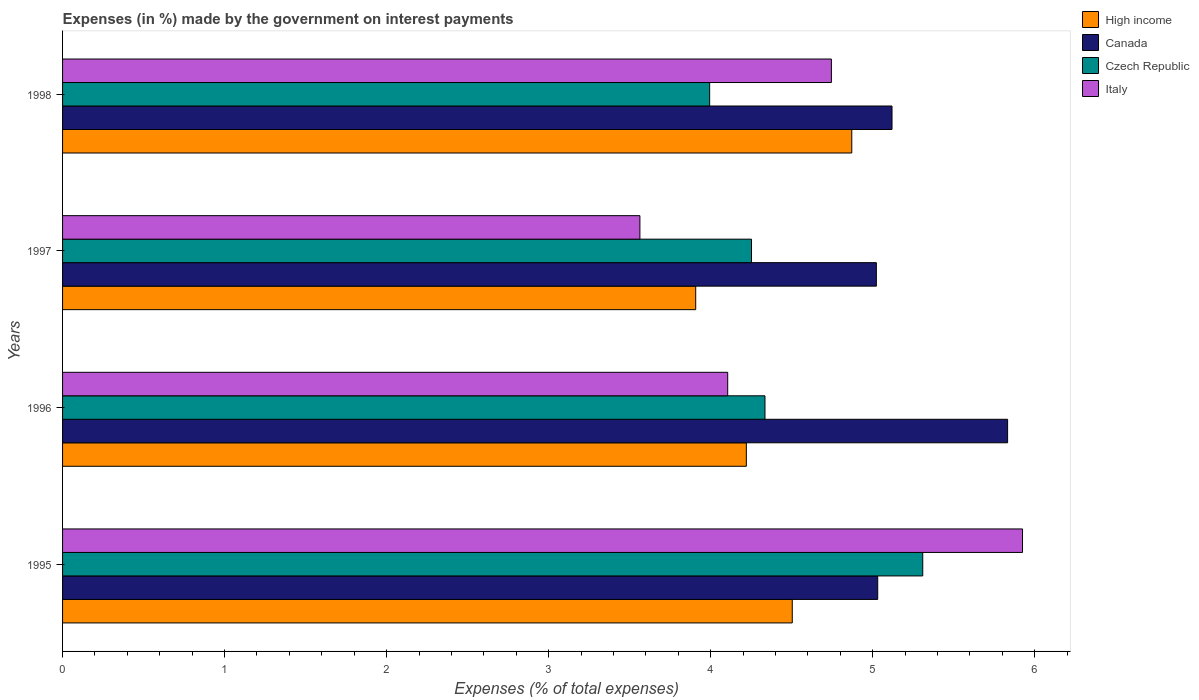How many groups of bars are there?
Make the answer very short. 4. Are the number of bars per tick equal to the number of legend labels?
Ensure brevity in your answer.  Yes. Are the number of bars on each tick of the Y-axis equal?
Your answer should be very brief. Yes. What is the label of the 4th group of bars from the top?
Provide a succinct answer. 1995. In how many cases, is the number of bars for a given year not equal to the number of legend labels?
Offer a terse response. 0. What is the percentage of expenses made by the government on interest payments in High income in 1998?
Give a very brief answer. 4.87. Across all years, what is the maximum percentage of expenses made by the government on interest payments in Italy?
Provide a short and direct response. 5.93. Across all years, what is the minimum percentage of expenses made by the government on interest payments in Italy?
Make the answer very short. 3.56. In which year was the percentage of expenses made by the government on interest payments in Italy maximum?
Your answer should be very brief. 1995. In which year was the percentage of expenses made by the government on interest payments in Czech Republic minimum?
Offer a terse response. 1998. What is the total percentage of expenses made by the government on interest payments in Czech Republic in the graph?
Make the answer very short. 17.89. What is the difference between the percentage of expenses made by the government on interest payments in Canada in 1995 and that in 1996?
Offer a very short reply. -0.8. What is the difference between the percentage of expenses made by the government on interest payments in High income in 1996 and the percentage of expenses made by the government on interest payments in Italy in 1997?
Give a very brief answer. 0.66. What is the average percentage of expenses made by the government on interest payments in Canada per year?
Make the answer very short. 5.25. In the year 1996, what is the difference between the percentage of expenses made by the government on interest payments in High income and percentage of expenses made by the government on interest payments in Canada?
Keep it short and to the point. -1.61. What is the ratio of the percentage of expenses made by the government on interest payments in High income in 1995 to that in 1997?
Keep it short and to the point. 1.15. Is the percentage of expenses made by the government on interest payments in Canada in 1997 less than that in 1998?
Ensure brevity in your answer.  Yes. What is the difference between the highest and the second highest percentage of expenses made by the government on interest payments in Czech Republic?
Your answer should be very brief. 0.97. What is the difference between the highest and the lowest percentage of expenses made by the government on interest payments in Canada?
Give a very brief answer. 0.81. In how many years, is the percentage of expenses made by the government on interest payments in Canada greater than the average percentage of expenses made by the government on interest payments in Canada taken over all years?
Offer a terse response. 1. Is the sum of the percentage of expenses made by the government on interest payments in High income in 1996 and 1998 greater than the maximum percentage of expenses made by the government on interest payments in Canada across all years?
Provide a short and direct response. Yes. Is it the case that in every year, the sum of the percentage of expenses made by the government on interest payments in High income and percentage of expenses made by the government on interest payments in Czech Republic is greater than the sum of percentage of expenses made by the government on interest payments in Italy and percentage of expenses made by the government on interest payments in Canada?
Ensure brevity in your answer.  No. Is it the case that in every year, the sum of the percentage of expenses made by the government on interest payments in High income and percentage of expenses made by the government on interest payments in Italy is greater than the percentage of expenses made by the government on interest payments in Czech Republic?
Your response must be concise. Yes. How many bars are there?
Make the answer very short. 16. Are all the bars in the graph horizontal?
Give a very brief answer. Yes. What is the difference between two consecutive major ticks on the X-axis?
Give a very brief answer. 1. Where does the legend appear in the graph?
Provide a succinct answer. Top right. How are the legend labels stacked?
Make the answer very short. Vertical. What is the title of the graph?
Your answer should be very brief. Expenses (in %) made by the government on interest payments. What is the label or title of the X-axis?
Your answer should be very brief. Expenses (% of total expenses). What is the label or title of the Y-axis?
Make the answer very short. Years. What is the Expenses (% of total expenses) of High income in 1995?
Your answer should be compact. 4.5. What is the Expenses (% of total expenses) of Canada in 1995?
Your answer should be compact. 5.03. What is the Expenses (% of total expenses) in Czech Republic in 1995?
Your response must be concise. 5.31. What is the Expenses (% of total expenses) in Italy in 1995?
Make the answer very short. 5.93. What is the Expenses (% of total expenses) in High income in 1996?
Keep it short and to the point. 4.22. What is the Expenses (% of total expenses) of Canada in 1996?
Provide a short and direct response. 5.83. What is the Expenses (% of total expenses) in Czech Republic in 1996?
Your response must be concise. 4.34. What is the Expenses (% of total expenses) in Italy in 1996?
Provide a succinct answer. 4.11. What is the Expenses (% of total expenses) in High income in 1997?
Provide a short and direct response. 3.91. What is the Expenses (% of total expenses) in Canada in 1997?
Provide a succinct answer. 5.02. What is the Expenses (% of total expenses) in Czech Republic in 1997?
Your answer should be very brief. 4.25. What is the Expenses (% of total expenses) of Italy in 1997?
Your answer should be compact. 3.56. What is the Expenses (% of total expenses) in High income in 1998?
Offer a very short reply. 4.87. What is the Expenses (% of total expenses) of Canada in 1998?
Make the answer very short. 5.12. What is the Expenses (% of total expenses) of Czech Republic in 1998?
Your response must be concise. 3.99. What is the Expenses (% of total expenses) of Italy in 1998?
Give a very brief answer. 4.75. Across all years, what is the maximum Expenses (% of total expenses) of High income?
Offer a terse response. 4.87. Across all years, what is the maximum Expenses (% of total expenses) in Canada?
Provide a succinct answer. 5.83. Across all years, what is the maximum Expenses (% of total expenses) in Czech Republic?
Provide a succinct answer. 5.31. Across all years, what is the maximum Expenses (% of total expenses) of Italy?
Ensure brevity in your answer.  5.93. Across all years, what is the minimum Expenses (% of total expenses) of High income?
Ensure brevity in your answer.  3.91. Across all years, what is the minimum Expenses (% of total expenses) in Canada?
Offer a terse response. 5.02. Across all years, what is the minimum Expenses (% of total expenses) in Czech Republic?
Your answer should be very brief. 3.99. Across all years, what is the minimum Expenses (% of total expenses) in Italy?
Your response must be concise. 3.56. What is the total Expenses (% of total expenses) in High income in the graph?
Give a very brief answer. 17.5. What is the total Expenses (% of total expenses) in Canada in the graph?
Make the answer very short. 21.01. What is the total Expenses (% of total expenses) of Czech Republic in the graph?
Provide a short and direct response. 17.89. What is the total Expenses (% of total expenses) of Italy in the graph?
Provide a short and direct response. 18.34. What is the difference between the Expenses (% of total expenses) of High income in 1995 and that in 1996?
Your answer should be very brief. 0.28. What is the difference between the Expenses (% of total expenses) of Canada in 1995 and that in 1996?
Make the answer very short. -0.8. What is the difference between the Expenses (% of total expenses) of Czech Republic in 1995 and that in 1996?
Keep it short and to the point. 0.97. What is the difference between the Expenses (% of total expenses) in Italy in 1995 and that in 1996?
Your response must be concise. 1.82. What is the difference between the Expenses (% of total expenses) of High income in 1995 and that in 1997?
Provide a succinct answer. 0.6. What is the difference between the Expenses (% of total expenses) of Canada in 1995 and that in 1997?
Make the answer very short. 0.01. What is the difference between the Expenses (% of total expenses) of Czech Republic in 1995 and that in 1997?
Your response must be concise. 1.06. What is the difference between the Expenses (% of total expenses) of Italy in 1995 and that in 1997?
Your answer should be very brief. 2.36. What is the difference between the Expenses (% of total expenses) of High income in 1995 and that in 1998?
Your response must be concise. -0.37. What is the difference between the Expenses (% of total expenses) of Canada in 1995 and that in 1998?
Ensure brevity in your answer.  -0.09. What is the difference between the Expenses (% of total expenses) in Czech Republic in 1995 and that in 1998?
Make the answer very short. 1.32. What is the difference between the Expenses (% of total expenses) in Italy in 1995 and that in 1998?
Offer a terse response. 1.18. What is the difference between the Expenses (% of total expenses) in High income in 1996 and that in 1997?
Your response must be concise. 0.31. What is the difference between the Expenses (% of total expenses) of Canada in 1996 and that in 1997?
Your answer should be compact. 0.81. What is the difference between the Expenses (% of total expenses) in Czech Republic in 1996 and that in 1997?
Your answer should be very brief. 0.08. What is the difference between the Expenses (% of total expenses) in Italy in 1996 and that in 1997?
Make the answer very short. 0.54. What is the difference between the Expenses (% of total expenses) of High income in 1996 and that in 1998?
Offer a terse response. -0.65. What is the difference between the Expenses (% of total expenses) of Canada in 1996 and that in 1998?
Your answer should be compact. 0.71. What is the difference between the Expenses (% of total expenses) of Czech Republic in 1996 and that in 1998?
Provide a short and direct response. 0.34. What is the difference between the Expenses (% of total expenses) in Italy in 1996 and that in 1998?
Make the answer very short. -0.64. What is the difference between the Expenses (% of total expenses) in High income in 1997 and that in 1998?
Give a very brief answer. -0.96. What is the difference between the Expenses (% of total expenses) of Canada in 1997 and that in 1998?
Your answer should be compact. -0.1. What is the difference between the Expenses (% of total expenses) in Czech Republic in 1997 and that in 1998?
Ensure brevity in your answer.  0.26. What is the difference between the Expenses (% of total expenses) of Italy in 1997 and that in 1998?
Ensure brevity in your answer.  -1.18. What is the difference between the Expenses (% of total expenses) in High income in 1995 and the Expenses (% of total expenses) in Canada in 1996?
Your answer should be compact. -1.33. What is the difference between the Expenses (% of total expenses) in High income in 1995 and the Expenses (% of total expenses) in Czech Republic in 1996?
Give a very brief answer. 0.17. What is the difference between the Expenses (% of total expenses) of High income in 1995 and the Expenses (% of total expenses) of Italy in 1996?
Your response must be concise. 0.4. What is the difference between the Expenses (% of total expenses) in Canada in 1995 and the Expenses (% of total expenses) in Czech Republic in 1996?
Offer a terse response. 0.7. What is the difference between the Expenses (% of total expenses) in Canada in 1995 and the Expenses (% of total expenses) in Italy in 1996?
Your answer should be very brief. 0.93. What is the difference between the Expenses (% of total expenses) in Czech Republic in 1995 and the Expenses (% of total expenses) in Italy in 1996?
Keep it short and to the point. 1.2. What is the difference between the Expenses (% of total expenses) of High income in 1995 and the Expenses (% of total expenses) of Canada in 1997?
Offer a terse response. -0.52. What is the difference between the Expenses (% of total expenses) of High income in 1995 and the Expenses (% of total expenses) of Czech Republic in 1997?
Your answer should be very brief. 0.25. What is the difference between the Expenses (% of total expenses) of High income in 1995 and the Expenses (% of total expenses) of Italy in 1997?
Offer a very short reply. 0.94. What is the difference between the Expenses (% of total expenses) of Canada in 1995 and the Expenses (% of total expenses) of Czech Republic in 1997?
Ensure brevity in your answer.  0.78. What is the difference between the Expenses (% of total expenses) in Canada in 1995 and the Expenses (% of total expenses) in Italy in 1997?
Offer a very short reply. 1.47. What is the difference between the Expenses (% of total expenses) in Czech Republic in 1995 and the Expenses (% of total expenses) in Italy in 1997?
Give a very brief answer. 1.75. What is the difference between the Expenses (% of total expenses) in High income in 1995 and the Expenses (% of total expenses) in Canada in 1998?
Your answer should be very brief. -0.62. What is the difference between the Expenses (% of total expenses) in High income in 1995 and the Expenses (% of total expenses) in Czech Republic in 1998?
Offer a terse response. 0.51. What is the difference between the Expenses (% of total expenses) of High income in 1995 and the Expenses (% of total expenses) of Italy in 1998?
Provide a succinct answer. -0.24. What is the difference between the Expenses (% of total expenses) in Canada in 1995 and the Expenses (% of total expenses) in Czech Republic in 1998?
Ensure brevity in your answer.  1.04. What is the difference between the Expenses (% of total expenses) in Canada in 1995 and the Expenses (% of total expenses) in Italy in 1998?
Give a very brief answer. 0.29. What is the difference between the Expenses (% of total expenses) of Czech Republic in 1995 and the Expenses (% of total expenses) of Italy in 1998?
Offer a terse response. 0.56. What is the difference between the Expenses (% of total expenses) in High income in 1996 and the Expenses (% of total expenses) in Canada in 1997?
Provide a short and direct response. -0.8. What is the difference between the Expenses (% of total expenses) in High income in 1996 and the Expenses (% of total expenses) in Czech Republic in 1997?
Ensure brevity in your answer.  -0.03. What is the difference between the Expenses (% of total expenses) of High income in 1996 and the Expenses (% of total expenses) of Italy in 1997?
Offer a terse response. 0.66. What is the difference between the Expenses (% of total expenses) in Canada in 1996 and the Expenses (% of total expenses) in Czech Republic in 1997?
Your response must be concise. 1.58. What is the difference between the Expenses (% of total expenses) in Canada in 1996 and the Expenses (% of total expenses) in Italy in 1997?
Provide a short and direct response. 2.27. What is the difference between the Expenses (% of total expenses) in Czech Republic in 1996 and the Expenses (% of total expenses) in Italy in 1997?
Give a very brief answer. 0.77. What is the difference between the Expenses (% of total expenses) in High income in 1996 and the Expenses (% of total expenses) in Canada in 1998?
Ensure brevity in your answer.  -0.9. What is the difference between the Expenses (% of total expenses) in High income in 1996 and the Expenses (% of total expenses) in Czech Republic in 1998?
Offer a very short reply. 0.23. What is the difference between the Expenses (% of total expenses) in High income in 1996 and the Expenses (% of total expenses) in Italy in 1998?
Give a very brief answer. -0.53. What is the difference between the Expenses (% of total expenses) in Canada in 1996 and the Expenses (% of total expenses) in Czech Republic in 1998?
Offer a very short reply. 1.84. What is the difference between the Expenses (% of total expenses) in Canada in 1996 and the Expenses (% of total expenses) in Italy in 1998?
Your response must be concise. 1.09. What is the difference between the Expenses (% of total expenses) in Czech Republic in 1996 and the Expenses (% of total expenses) in Italy in 1998?
Your answer should be very brief. -0.41. What is the difference between the Expenses (% of total expenses) in High income in 1997 and the Expenses (% of total expenses) in Canada in 1998?
Make the answer very short. -1.21. What is the difference between the Expenses (% of total expenses) of High income in 1997 and the Expenses (% of total expenses) of Czech Republic in 1998?
Keep it short and to the point. -0.09. What is the difference between the Expenses (% of total expenses) in High income in 1997 and the Expenses (% of total expenses) in Italy in 1998?
Your answer should be compact. -0.84. What is the difference between the Expenses (% of total expenses) of Canada in 1997 and the Expenses (% of total expenses) of Italy in 1998?
Provide a succinct answer. 0.28. What is the difference between the Expenses (% of total expenses) in Czech Republic in 1997 and the Expenses (% of total expenses) in Italy in 1998?
Provide a succinct answer. -0.49. What is the average Expenses (% of total expenses) of High income per year?
Offer a very short reply. 4.38. What is the average Expenses (% of total expenses) of Canada per year?
Provide a short and direct response. 5.25. What is the average Expenses (% of total expenses) in Czech Republic per year?
Your response must be concise. 4.47. What is the average Expenses (% of total expenses) in Italy per year?
Offer a very short reply. 4.58. In the year 1995, what is the difference between the Expenses (% of total expenses) in High income and Expenses (% of total expenses) in Canada?
Provide a short and direct response. -0.53. In the year 1995, what is the difference between the Expenses (% of total expenses) in High income and Expenses (% of total expenses) in Czech Republic?
Your answer should be compact. -0.81. In the year 1995, what is the difference between the Expenses (% of total expenses) of High income and Expenses (% of total expenses) of Italy?
Offer a very short reply. -1.42. In the year 1995, what is the difference between the Expenses (% of total expenses) in Canada and Expenses (% of total expenses) in Czech Republic?
Provide a short and direct response. -0.28. In the year 1995, what is the difference between the Expenses (% of total expenses) of Canada and Expenses (% of total expenses) of Italy?
Provide a short and direct response. -0.89. In the year 1995, what is the difference between the Expenses (% of total expenses) in Czech Republic and Expenses (% of total expenses) in Italy?
Provide a short and direct response. -0.62. In the year 1996, what is the difference between the Expenses (% of total expenses) of High income and Expenses (% of total expenses) of Canada?
Ensure brevity in your answer.  -1.61. In the year 1996, what is the difference between the Expenses (% of total expenses) in High income and Expenses (% of total expenses) in Czech Republic?
Offer a terse response. -0.12. In the year 1996, what is the difference between the Expenses (% of total expenses) in High income and Expenses (% of total expenses) in Italy?
Offer a terse response. 0.12. In the year 1996, what is the difference between the Expenses (% of total expenses) in Canada and Expenses (% of total expenses) in Czech Republic?
Ensure brevity in your answer.  1.5. In the year 1996, what is the difference between the Expenses (% of total expenses) in Canada and Expenses (% of total expenses) in Italy?
Your answer should be compact. 1.73. In the year 1996, what is the difference between the Expenses (% of total expenses) in Czech Republic and Expenses (% of total expenses) in Italy?
Provide a succinct answer. 0.23. In the year 1997, what is the difference between the Expenses (% of total expenses) in High income and Expenses (% of total expenses) in Canada?
Offer a very short reply. -1.12. In the year 1997, what is the difference between the Expenses (% of total expenses) in High income and Expenses (% of total expenses) in Czech Republic?
Provide a short and direct response. -0.34. In the year 1997, what is the difference between the Expenses (% of total expenses) of High income and Expenses (% of total expenses) of Italy?
Make the answer very short. 0.34. In the year 1997, what is the difference between the Expenses (% of total expenses) in Canada and Expenses (% of total expenses) in Czech Republic?
Give a very brief answer. 0.77. In the year 1997, what is the difference between the Expenses (% of total expenses) of Canada and Expenses (% of total expenses) of Italy?
Give a very brief answer. 1.46. In the year 1997, what is the difference between the Expenses (% of total expenses) in Czech Republic and Expenses (% of total expenses) in Italy?
Give a very brief answer. 0.69. In the year 1998, what is the difference between the Expenses (% of total expenses) of High income and Expenses (% of total expenses) of Canada?
Provide a succinct answer. -0.25. In the year 1998, what is the difference between the Expenses (% of total expenses) of High income and Expenses (% of total expenses) of Czech Republic?
Ensure brevity in your answer.  0.88. In the year 1998, what is the difference between the Expenses (% of total expenses) of High income and Expenses (% of total expenses) of Italy?
Your answer should be very brief. 0.13. In the year 1998, what is the difference between the Expenses (% of total expenses) in Canada and Expenses (% of total expenses) in Czech Republic?
Provide a succinct answer. 1.13. In the year 1998, what is the difference between the Expenses (% of total expenses) in Canada and Expenses (% of total expenses) in Italy?
Ensure brevity in your answer.  0.37. In the year 1998, what is the difference between the Expenses (% of total expenses) in Czech Republic and Expenses (% of total expenses) in Italy?
Ensure brevity in your answer.  -0.75. What is the ratio of the Expenses (% of total expenses) of High income in 1995 to that in 1996?
Offer a very short reply. 1.07. What is the ratio of the Expenses (% of total expenses) of Canada in 1995 to that in 1996?
Provide a succinct answer. 0.86. What is the ratio of the Expenses (% of total expenses) in Czech Republic in 1995 to that in 1996?
Your answer should be compact. 1.22. What is the ratio of the Expenses (% of total expenses) of Italy in 1995 to that in 1996?
Make the answer very short. 1.44. What is the ratio of the Expenses (% of total expenses) of High income in 1995 to that in 1997?
Your response must be concise. 1.15. What is the ratio of the Expenses (% of total expenses) of Canada in 1995 to that in 1997?
Give a very brief answer. 1. What is the ratio of the Expenses (% of total expenses) in Czech Republic in 1995 to that in 1997?
Your answer should be very brief. 1.25. What is the ratio of the Expenses (% of total expenses) in Italy in 1995 to that in 1997?
Provide a short and direct response. 1.66. What is the ratio of the Expenses (% of total expenses) of High income in 1995 to that in 1998?
Keep it short and to the point. 0.92. What is the ratio of the Expenses (% of total expenses) of Canada in 1995 to that in 1998?
Your answer should be compact. 0.98. What is the ratio of the Expenses (% of total expenses) in Czech Republic in 1995 to that in 1998?
Provide a short and direct response. 1.33. What is the ratio of the Expenses (% of total expenses) in Italy in 1995 to that in 1998?
Your response must be concise. 1.25. What is the ratio of the Expenses (% of total expenses) in Canada in 1996 to that in 1997?
Provide a succinct answer. 1.16. What is the ratio of the Expenses (% of total expenses) of Czech Republic in 1996 to that in 1997?
Your answer should be very brief. 1.02. What is the ratio of the Expenses (% of total expenses) of Italy in 1996 to that in 1997?
Provide a short and direct response. 1.15. What is the ratio of the Expenses (% of total expenses) in High income in 1996 to that in 1998?
Ensure brevity in your answer.  0.87. What is the ratio of the Expenses (% of total expenses) of Canada in 1996 to that in 1998?
Provide a succinct answer. 1.14. What is the ratio of the Expenses (% of total expenses) of Czech Republic in 1996 to that in 1998?
Provide a succinct answer. 1.09. What is the ratio of the Expenses (% of total expenses) in Italy in 1996 to that in 1998?
Give a very brief answer. 0.87. What is the ratio of the Expenses (% of total expenses) in High income in 1997 to that in 1998?
Provide a short and direct response. 0.8. What is the ratio of the Expenses (% of total expenses) in Canada in 1997 to that in 1998?
Make the answer very short. 0.98. What is the ratio of the Expenses (% of total expenses) of Czech Republic in 1997 to that in 1998?
Your answer should be very brief. 1.06. What is the ratio of the Expenses (% of total expenses) in Italy in 1997 to that in 1998?
Your response must be concise. 0.75. What is the difference between the highest and the second highest Expenses (% of total expenses) of High income?
Offer a very short reply. 0.37. What is the difference between the highest and the second highest Expenses (% of total expenses) of Canada?
Offer a terse response. 0.71. What is the difference between the highest and the second highest Expenses (% of total expenses) of Czech Republic?
Your answer should be compact. 0.97. What is the difference between the highest and the second highest Expenses (% of total expenses) in Italy?
Provide a short and direct response. 1.18. What is the difference between the highest and the lowest Expenses (% of total expenses) of High income?
Your response must be concise. 0.96. What is the difference between the highest and the lowest Expenses (% of total expenses) in Canada?
Your answer should be very brief. 0.81. What is the difference between the highest and the lowest Expenses (% of total expenses) of Czech Republic?
Your response must be concise. 1.32. What is the difference between the highest and the lowest Expenses (% of total expenses) of Italy?
Keep it short and to the point. 2.36. 